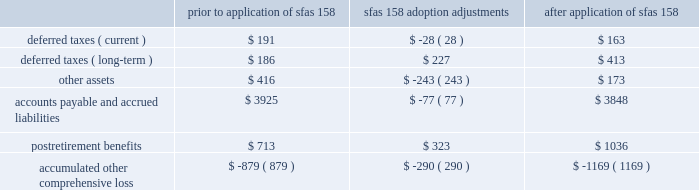Part ii , item 8 20 .
Pension and other benefit plans adoption of sfas 158 in september 2006 , the financial accounting standards board issued sfas 158 ( employer 2019s accounting for defined benefit pension and other postretirement plans , an amendment of fasb statements no .
87 , 88 , 106 and 132 ( r ) ) .
Sfas 158 required schlumberger to recognize the funded status ( i.e. , the difference between the fair value of plan assets and the benefit obligation ) of its defined benefit pension and other postretirement plans ( collectively 201cpostretirement benefit plans 201d ) in its december 31 , 2006 consolidated balance sheet , with a corresponding adjustment to accumulated other comprehensive income , net of tax .
The adjustment to accumulated other comprehensive income at adoption represents the net unrecognized actuarial losses and unrecognized prior service costs which were previously netted against schlumberger 2019s postretirement benefit plans 2019 funded status in the consolidated balance sheet pursuant to the provisions of sfas 87 ( employers 2019 accounting for pensions ) and sfas 106 ( employer 2019s accounting for postretirement benefits other than pensions ) .
These amounts will subsequently be recognized as net periodic postretirement cost consistent with schlumberger 2019s historical accounting policy for amortizing such amounts .
The adoption of sfas 158 had no effect on schlumberger 2019s consolidated statement of income for the year ended december 31 , 2006 , or for any prior period , and it will not affect schlumberger 2019s operating results in future periods .
Additionally , sfas 158 did not have an effect on schlumberger 2019s consolidated balance sheet at december 31 , sfas 158 also required companies to measure the fair value of plan assets and benefit obligations as of the date of the fiscal year-end balance sheet .
This provision of sfas 158 is not applicable as schlumberger already uses a measurement date of december 31 for its postretirement benefit plans .
The incremental effect of applying sfas 158 on the consolidated balance sheet at december 31 , 2006 for all of schlumberger 2019s postretirement benefit plans is presented in the table : ( stated in millions ) prior to application of sfas 158 sfas 158 adoption adjustments application of sfas 158 .
As a result of the adoption of sfas 158 , schlumberger 2019s total liabilities increased by approximately 2% ( 2 % ) and stockholders 2019 equity decreased by approximately 3% ( 3 % ) .
The impact on schlumberger 2019s total assets was insignificant .
United states defined benefit pension plans schlumberger and its united states subsidiary sponsor several defined benefit pension plans that cover substantially all employees hired prior to october 1 , 2004 .
The benefits are based on years of service and compensation on a career-average pay basis .
The funding policy with respect to qualified pension plans is to annually contribute amounts that are based upon a number of factors including the actuarial accrued liability , amounts that are deductible for income tax purposes , legal funding requirements and available cash flow .
These contributions are intended to provide for benefits earned to date and those expected to be earned in the future. .
By how much did sfas 158 adoption adjustments increase postretirement benefits? 
Computations: (323 / 713)
Answer: 0.45302. Part ii , item 8 20 .
Pension and other benefit plans adoption of sfas 158 in september 2006 , the financial accounting standards board issued sfas 158 ( employer 2019s accounting for defined benefit pension and other postretirement plans , an amendment of fasb statements no .
87 , 88 , 106 and 132 ( r ) ) .
Sfas 158 required schlumberger to recognize the funded status ( i.e. , the difference between the fair value of plan assets and the benefit obligation ) of its defined benefit pension and other postretirement plans ( collectively 201cpostretirement benefit plans 201d ) in its december 31 , 2006 consolidated balance sheet , with a corresponding adjustment to accumulated other comprehensive income , net of tax .
The adjustment to accumulated other comprehensive income at adoption represents the net unrecognized actuarial losses and unrecognized prior service costs which were previously netted against schlumberger 2019s postretirement benefit plans 2019 funded status in the consolidated balance sheet pursuant to the provisions of sfas 87 ( employers 2019 accounting for pensions ) and sfas 106 ( employer 2019s accounting for postretirement benefits other than pensions ) .
These amounts will subsequently be recognized as net periodic postretirement cost consistent with schlumberger 2019s historical accounting policy for amortizing such amounts .
The adoption of sfas 158 had no effect on schlumberger 2019s consolidated statement of income for the year ended december 31 , 2006 , or for any prior period , and it will not affect schlumberger 2019s operating results in future periods .
Additionally , sfas 158 did not have an effect on schlumberger 2019s consolidated balance sheet at december 31 , sfas 158 also required companies to measure the fair value of plan assets and benefit obligations as of the date of the fiscal year-end balance sheet .
This provision of sfas 158 is not applicable as schlumberger already uses a measurement date of december 31 for its postretirement benefit plans .
The incremental effect of applying sfas 158 on the consolidated balance sheet at december 31 , 2006 for all of schlumberger 2019s postretirement benefit plans is presented in the table : ( stated in millions ) prior to application of sfas 158 sfas 158 adoption adjustments application of sfas 158 .
As a result of the adoption of sfas 158 , schlumberger 2019s total liabilities increased by approximately 2% ( 2 % ) and stockholders 2019 equity decreased by approximately 3% ( 3 % ) .
The impact on schlumberger 2019s total assets was insignificant .
United states defined benefit pension plans schlumberger and its united states subsidiary sponsor several defined benefit pension plans that cover substantially all employees hired prior to october 1 , 2004 .
The benefits are based on years of service and compensation on a career-average pay basis .
The funding policy with respect to qualified pension plans is to annually contribute amounts that are based upon a number of factors including the actuarial accrued liability , amounts that are deductible for income tax purposes , legal funding requirements and available cash flow .
These contributions are intended to provide for benefits earned to date and those expected to be earned in the future. .
What is the percent of the sfas 158 adoption adjustments for the deferred taxes to the amount prior to the adjustments? 
Rationale: the percent change is the amount divide by the total amount
Computations: ((28 * const_m1) / 191)
Answer: -0.1466. 